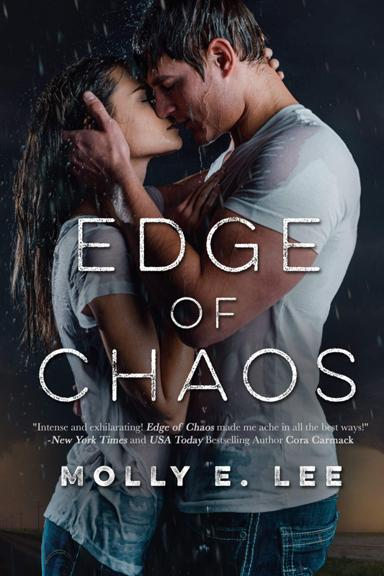What does the reviewer say about the book? Cora Carmack, a renowned New York Times and USA Today bestselling author, praises 'Edge of Chaos' as intense and exhilarating. She describes its emotional depth by mentioning it made her 'ache in all the best ways', suggesting a deeply impactful reading experience. 